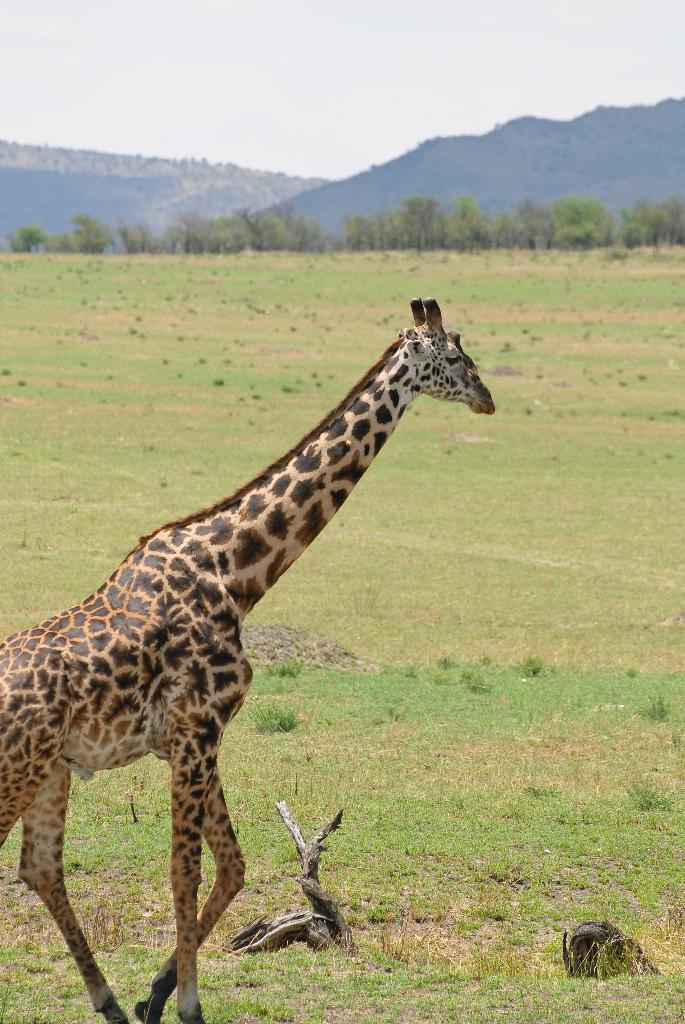What type of terrain is visible in the image? There are hills and grassy land visible in the image. What type of vegetation is present in the image? There are many trees in the image. What can be seen in the sky in the image? The sky is visible in the image. Is there any wildlife present in the image? Yes, there is an animal in the image. What type of quilt is being used by the kitten to play in the image? There is no kitten or quilt present in the image. How does the animal play with the trees in the image? The image does not depict the animal playing with the trees; it simply shows the animal in the landscape. 